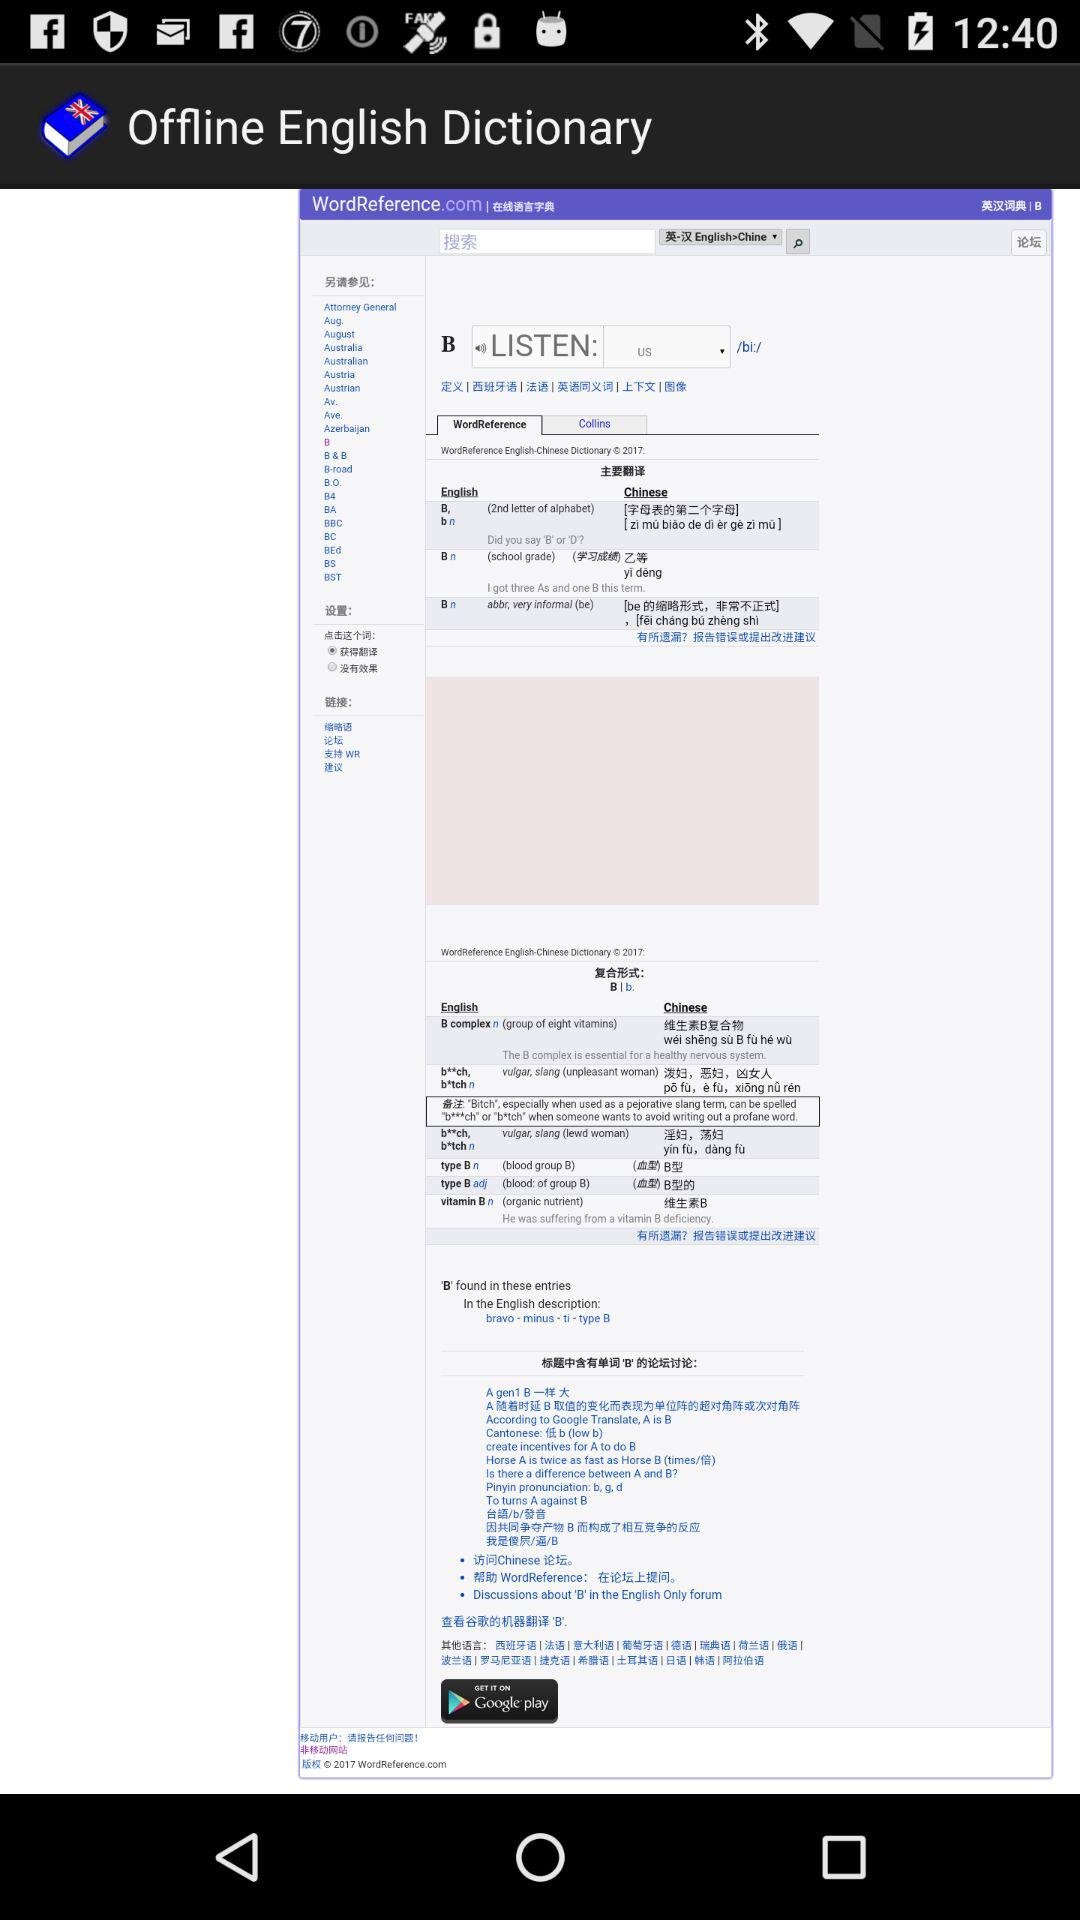What’s the app name? The app name is "Offline English Dictionary". 